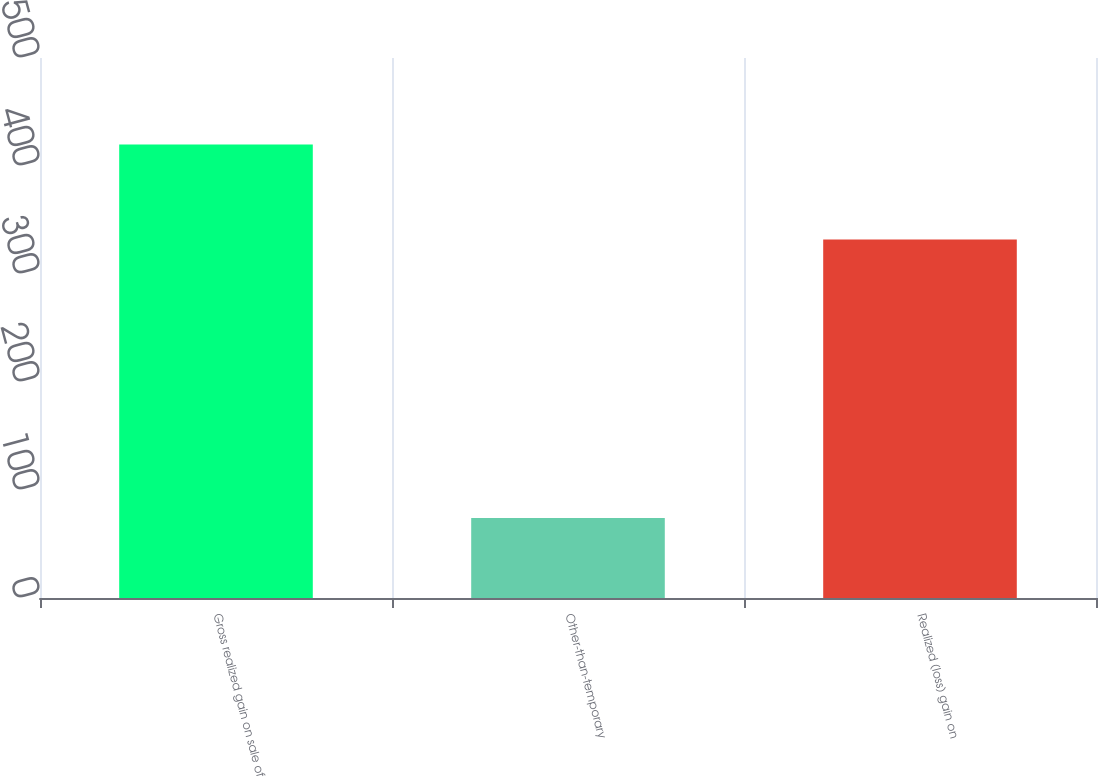Convert chart. <chart><loc_0><loc_0><loc_500><loc_500><bar_chart><fcel>Gross realized gain on sale of<fcel>Other-than-temporary<fcel>Realized (loss) gain on<nl><fcel>420<fcel>74<fcel>332<nl></chart> 